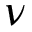Convert formula to latex. <formula><loc_0><loc_0><loc_500><loc_500>\nu</formula> 